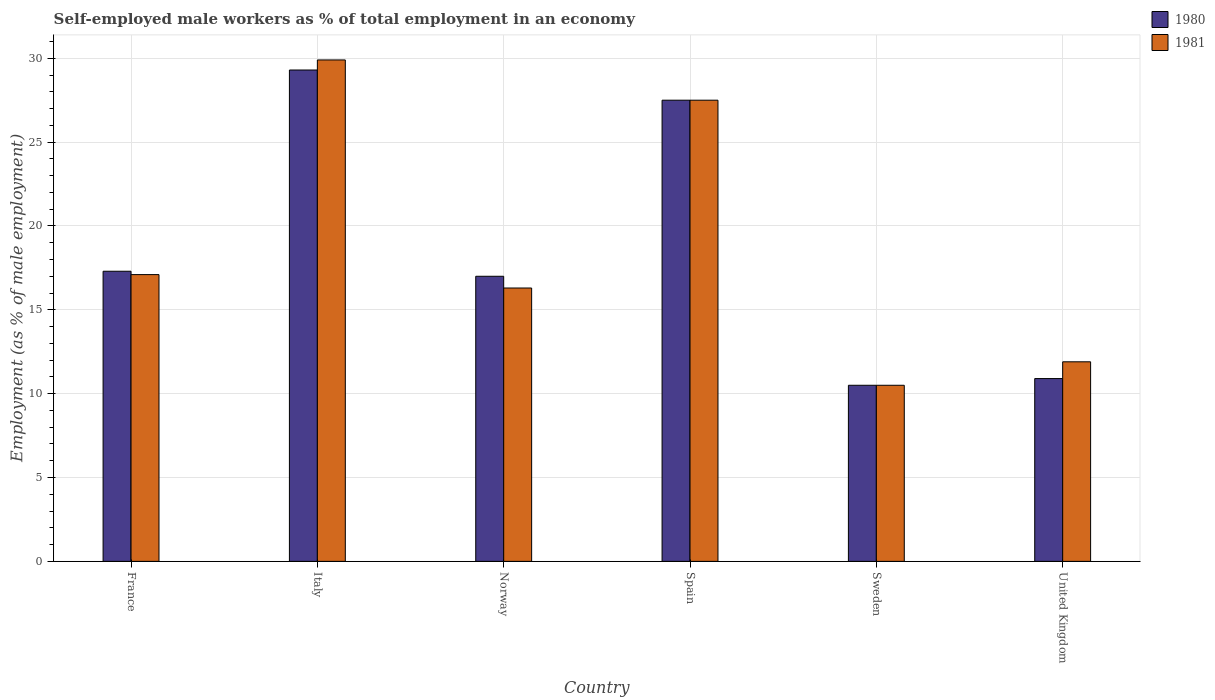How many different coloured bars are there?
Provide a short and direct response. 2. How many groups of bars are there?
Offer a very short reply. 6. Are the number of bars per tick equal to the number of legend labels?
Your answer should be very brief. Yes. How many bars are there on the 2nd tick from the left?
Offer a very short reply. 2. How many bars are there on the 6th tick from the right?
Your response must be concise. 2. What is the label of the 2nd group of bars from the left?
Your response must be concise. Italy. What is the percentage of self-employed male workers in 1981 in United Kingdom?
Your answer should be compact. 11.9. Across all countries, what is the maximum percentage of self-employed male workers in 1981?
Ensure brevity in your answer.  29.9. Across all countries, what is the minimum percentage of self-employed male workers in 1980?
Provide a succinct answer. 10.5. In which country was the percentage of self-employed male workers in 1981 maximum?
Offer a very short reply. Italy. In which country was the percentage of self-employed male workers in 1981 minimum?
Keep it short and to the point. Sweden. What is the total percentage of self-employed male workers in 1980 in the graph?
Provide a short and direct response. 112.5. What is the difference between the percentage of self-employed male workers in 1980 in France and that in Norway?
Keep it short and to the point. 0.3. What is the difference between the percentage of self-employed male workers in 1981 in Italy and the percentage of self-employed male workers in 1980 in Spain?
Offer a terse response. 2.4. What is the average percentage of self-employed male workers in 1981 per country?
Ensure brevity in your answer.  18.87. What is the difference between the percentage of self-employed male workers of/in 1981 and percentage of self-employed male workers of/in 1980 in Norway?
Keep it short and to the point. -0.7. In how many countries, is the percentage of self-employed male workers in 1980 greater than 26 %?
Offer a very short reply. 2. What is the ratio of the percentage of self-employed male workers in 1981 in France to that in Sweden?
Provide a succinct answer. 1.63. Is the percentage of self-employed male workers in 1981 in Italy less than that in Sweden?
Provide a short and direct response. No. What is the difference between the highest and the second highest percentage of self-employed male workers in 1980?
Your response must be concise. -10.2. What is the difference between the highest and the lowest percentage of self-employed male workers in 1980?
Provide a short and direct response. 18.8. Is the sum of the percentage of self-employed male workers in 1981 in France and Spain greater than the maximum percentage of self-employed male workers in 1980 across all countries?
Offer a terse response. Yes. What does the 1st bar from the left in Spain represents?
Give a very brief answer. 1980. Are the values on the major ticks of Y-axis written in scientific E-notation?
Give a very brief answer. No. Does the graph contain any zero values?
Give a very brief answer. No. How many legend labels are there?
Give a very brief answer. 2. How are the legend labels stacked?
Provide a succinct answer. Vertical. What is the title of the graph?
Your answer should be very brief. Self-employed male workers as % of total employment in an economy. Does "2014" appear as one of the legend labels in the graph?
Provide a succinct answer. No. What is the label or title of the Y-axis?
Provide a succinct answer. Employment (as % of male employment). What is the Employment (as % of male employment) in 1980 in France?
Keep it short and to the point. 17.3. What is the Employment (as % of male employment) of 1981 in France?
Ensure brevity in your answer.  17.1. What is the Employment (as % of male employment) of 1980 in Italy?
Provide a succinct answer. 29.3. What is the Employment (as % of male employment) of 1981 in Italy?
Ensure brevity in your answer.  29.9. What is the Employment (as % of male employment) of 1981 in Norway?
Offer a terse response. 16.3. What is the Employment (as % of male employment) in 1981 in Spain?
Make the answer very short. 27.5. What is the Employment (as % of male employment) in 1980 in Sweden?
Make the answer very short. 10.5. What is the Employment (as % of male employment) of 1981 in Sweden?
Your response must be concise. 10.5. What is the Employment (as % of male employment) of 1980 in United Kingdom?
Make the answer very short. 10.9. What is the Employment (as % of male employment) of 1981 in United Kingdom?
Give a very brief answer. 11.9. Across all countries, what is the maximum Employment (as % of male employment) in 1980?
Keep it short and to the point. 29.3. Across all countries, what is the maximum Employment (as % of male employment) in 1981?
Ensure brevity in your answer.  29.9. What is the total Employment (as % of male employment) in 1980 in the graph?
Your answer should be very brief. 112.5. What is the total Employment (as % of male employment) of 1981 in the graph?
Offer a very short reply. 113.2. What is the difference between the Employment (as % of male employment) in 1981 in France and that in Italy?
Provide a succinct answer. -12.8. What is the difference between the Employment (as % of male employment) in 1980 in France and that in Norway?
Make the answer very short. 0.3. What is the difference between the Employment (as % of male employment) in 1981 in France and that in Norway?
Offer a terse response. 0.8. What is the difference between the Employment (as % of male employment) of 1980 in France and that in United Kingdom?
Ensure brevity in your answer.  6.4. What is the difference between the Employment (as % of male employment) in 1981 in France and that in United Kingdom?
Provide a succinct answer. 5.2. What is the difference between the Employment (as % of male employment) of 1980 in Italy and that in United Kingdom?
Your response must be concise. 18.4. What is the difference between the Employment (as % of male employment) in 1981 in Norway and that in Sweden?
Provide a short and direct response. 5.8. What is the difference between the Employment (as % of male employment) in 1980 in Norway and that in United Kingdom?
Make the answer very short. 6.1. What is the difference between the Employment (as % of male employment) in 1981 in Sweden and that in United Kingdom?
Your answer should be compact. -1.4. What is the difference between the Employment (as % of male employment) of 1980 in France and the Employment (as % of male employment) of 1981 in Spain?
Provide a short and direct response. -10.2. What is the difference between the Employment (as % of male employment) in 1980 in France and the Employment (as % of male employment) in 1981 in Sweden?
Keep it short and to the point. 6.8. What is the difference between the Employment (as % of male employment) in 1980 in Italy and the Employment (as % of male employment) in 1981 in Norway?
Make the answer very short. 13. What is the difference between the Employment (as % of male employment) in 1980 in Norway and the Employment (as % of male employment) in 1981 in Spain?
Offer a very short reply. -10.5. What is the difference between the Employment (as % of male employment) in 1980 in Norway and the Employment (as % of male employment) in 1981 in Sweden?
Provide a short and direct response. 6.5. What is the difference between the Employment (as % of male employment) in 1980 in Spain and the Employment (as % of male employment) in 1981 in United Kingdom?
Make the answer very short. 15.6. What is the average Employment (as % of male employment) of 1980 per country?
Provide a succinct answer. 18.75. What is the average Employment (as % of male employment) in 1981 per country?
Your response must be concise. 18.87. What is the difference between the Employment (as % of male employment) of 1980 and Employment (as % of male employment) of 1981 in France?
Your answer should be compact. 0.2. What is the difference between the Employment (as % of male employment) of 1980 and Employment (as % of male employment) of 1981 in Italy?
Make the answer very short. -0.6. What is the ratio of the Employment (as % of male employment) of 1980 in France to that in Italy?
Offer a very short reply. 0.59. What is the ratio of the Employment (as % of male employment) in 1981 in France to that in Italy?
Provide a succinct answer. 0.57. What is the ratio of the Employment (as % of male employment) of 1980 in France to that in Norway?
Provide a short and direct response. 1.02. What is the ratio of the Employment (as % of male employment) of 1981 in France to that in Norway?
Make the answer very short. 1.05. What is the ratio of the Employment (as % of male employment) in 1980 in France to that in Spain?
Offer a terse response. 0.63. What is the ratio of the Employment (as % of male employment) of 1981 in France to that in Spain?
Offer a very short reply. 0.62. What is the ratio of the Employment (as % of male employment) in 1980 in France to that in Sweden?
Keep it short and to the point. 1.65. What is the ratio of the Employment (as % of male employment) of 1981 in France to that in Sweden?
Provide a short and direct response. 1.63. What is the ratio of the Employment (as % of male employment) of 1980 in France to that in United Kingdom?
Your answer should be very brief. 1.59. What is the ratio of the Employment (as % of male employment) in 1981 in France to that in United Kingdom?
Provide a short and direct response. 1.44. What is the ratio of the Employment (as % of male employment) of 1980 in Italy to that in Norway?
Provide a short and direct response. 1.72. What is the ratio of the Employment (as % of male employment) in 1981 in Italy to that in Norway?
Give a very brief answer. 1.83. What is the ratio of the Employment (as % of male employment) in 1980 in Italy to that in Spain?
Make the answer very short. 1.07. What is the ratio of the Employment (as % of male employment) of 1981 in Italy to that in Spain?
Provide a succinct answer. 1.09. What is the ratio of the Employment (as % of male employment) in 1980 in Italy to that in Sweden?
Offer a terse response. 2.79. What is the ratio of the Employment (as % of male employment) in 1981 in Italy to that in Sweden?
Your answer should be very brief. 2.85. What is the ratio of the Employment (as % of male employment) in 1980 in Italy to that in United Kingdom?
Your answer should be very brief. 2.69. What is the ratio of the Employment (as % of male employment) in 1981 in Italy to that in United Kingdom?
Provide a succinct answer. 2.51. What is the ratio of the Employment (as % of male employment) in 1980 in Norway to that in Spain?
Provide a short and direct response. 0.62. What is the ratio of the Employment (as % of male employment) in 1981 in Norway to that in Spain?
Keep it short and to the point. 0.59. What is the ratio of the Employment (as % of male employment) in 1980 in Norway to that in Sweden?
Your answer should be compact. 1.62. What is the ratio of the Employment (as % of male employment) in 1981 in Norway to that in Sweden?
Your answer should be compact. 1.55. What is the ratio of the Employment (as % of male employment) in 1980 in Norway to that in United Kingdom?
Offer a very short reply. 1.56. What is the ratio of the Employment (as % of male employment) of 1981 in Norway to that in United Kingdom?
Provide a succinct answer. 1.37. What is the ratio of the Employment (as % of male employment) of 1980 in Spain to that in Sweden?
Keep it short and to the point. 2.62. What is the ratio of the Employment (as % of male employment) of 1981 in Spain to that in Sweden?
Your response must be concise. 2.62. What is the ratio of the Employment (as % of male employment) in 1980 in Spain to that in United Kingdom?
Offer a terse response. 2.52. What is the ratio of the Employment (as % of male employment) of 1981 in Spain to that in United Kingdom?
Make the answer very short. 2.31. What is the ratio of the Employment (as % of male employment) of 1980 in Sweden to that in United Kingdom?
Your response must be concise. 0.96. What is the ratio of the Employment (as % of male employment) of 1981 in Sweden to that in United Kingdom?
Ensure brevity in your answer.  0.88. What is the difference between the highest and the second highest Employment (as % of male employment) of 1980?
Ensure brevity in your answer.  1.8. What is the difference between the highest and the second highest Employment (as % of male employment) in 1981?
Make the answer very short. 2.4. What is the difference between the highest and the lowest Employment (as % of male employment) in 1981?
Offer a very short reply. 19.4. 